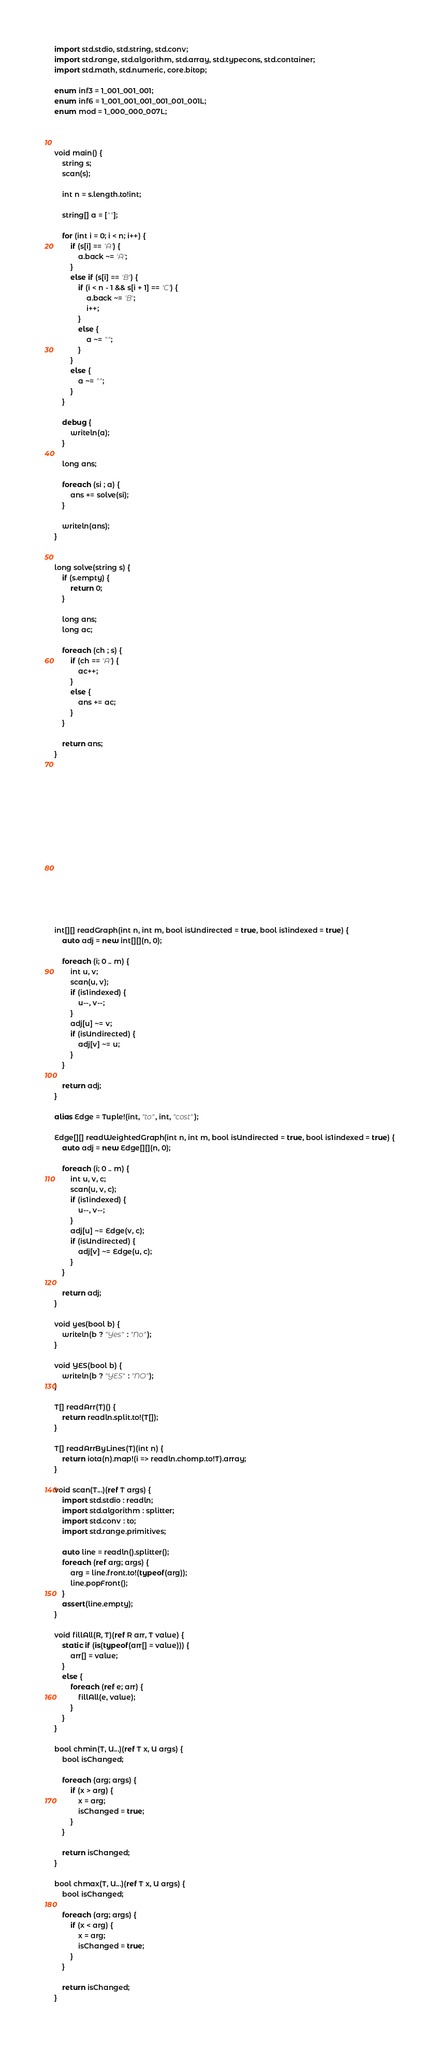Convert code to text. <code><loc_0><loc_0><loc_500><loc_500><_D_>import std.stdio, std.string, std.conv;
import std.range, std.algorithm, std.array, std.typecons, std.container;
import std.math, std.numeric, core.bitop;

enum inf3 = 1_001_001_001;
enum inf6 = 1_001_001_001_001_001_001L;
enum mod = 1_000_000_007L;



void main() {
    string s;
    scan(s);

    int n = s.length.to!int;

    string[] a = [""];

    for (int i = 0; i < n; i++) {
        if (s[i] == 'A') {
            a.back ~= 'A';
        }
        else if (s[i] == 'B') {
            if (i < n - 1 && s[i + 1] == 'C') {
                a.back ~= 'B';
                i++;
            }
            else {
                a ~= "";
            }
        }
        else {
            a ~= "";
        }
    }

    debug {
        writeln(a);
    }

    long ans;

    foreach (si ; a) {
        ans += solve(si);
    }

    writeln(ans);
}


long solve(string s) {
    if (s.empty) {
        return 0;
    }

    long ans;
    long ac;

    foreach (ch ; s) {
        if (ch == 'A') {
            ac++;
        }
        else {
            ans += ac;
        }
    }

    return ans;
}
















int[][] readGraph(int n, int m, bool isUndirected = true, bool is1indexed = true) {
    auto adj = new int[][](n, 0);

    foreach (i; 0 .. m) {
        int u, v;
        scan(u, v);
        if (is1indexed) {
            u--, v--;
        }
        adj[u] ~= v;
        if (isUndirected) {
            adj[v] ~= u;
        }
    }

    return adj;
}

alias Edge = Tuple!(int, "to", int, "cost");

Edge[][] readWeightedGraph(int n, int m, bool isUndirected = true, bool is1indexed = true) {
    auto adj = new Edge[][](n, 0);

    foreach (i; 0 .. m) {
        int u, v, c;
        scan(u, v, c);
        if (is1indexed) {
            u--, v--;
        }
        adj[u] ~= Edge(v, c);
        if (isUndirected) {
            adj[v] ~= Edge(u, c);
        }
    }

    return adj;
}

void yes(bool b) {
    writeln(b ? "Yes" : "No");
}

void YES(bool b) {
    writeln(b ? "YES" : "NO");
}

T[] readArr(T)() {
    return readln.split.to!(T[]);
}

T[] readArrByLines(T)(int n) {
    return iota(n).map!(i => readln.chomp.to!T).array;
}

void scan(T...)(ref T args) {
    import std.stdio : readln;
    import std.algorithm : splitter;
    import std.conv : to;
    import std.range.primitives;

    auto line = readln().splitter();
    foreach (ref arg; args) {
        arg = line.front.to!(typeof(arg));
        line.popFront();
    }
    assert(line.empty);
}

void fillAll(R, T)(ref R arr, T value) {
    static if (is(typeof(arr[] = value))) {
        arr[] = value;
    }
    else {
        foreach (ref e; arr) {
            fillAll(e, value);
        }
    }
}

bool chmin(T, U...)(ref T x, U args) {
    bool isChanged;

    foreach (arg; args) {
        if (x > arg) {
            x = arg;
            isChanged = true;
        }
    }

    return isChanged;
}

bool chmax(T, U...)(ref T x, U args) {
    bool isChanged;

    foreach (arg; args) {
        if (x < arg) {
            x = arg;
            isChanged = true;
        }
    }

    return isChanged;
}
</code> 